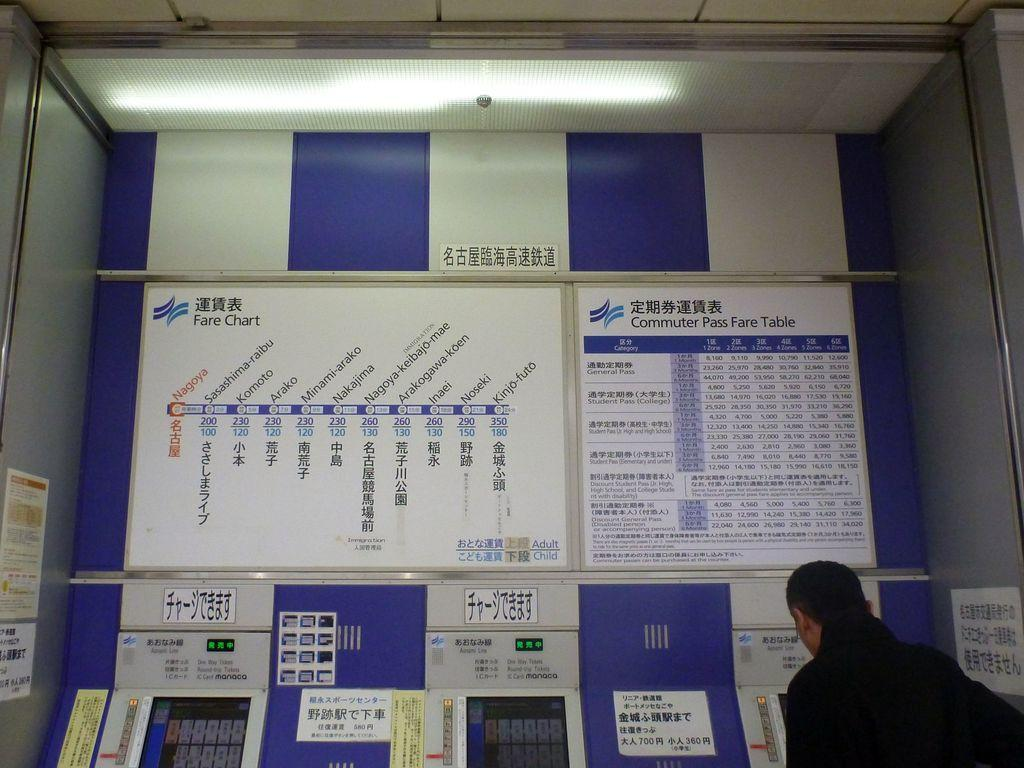Provide a one-sentence caption for the provided image. A man is buying a ticket at the Commuter Pass ticket machine. 